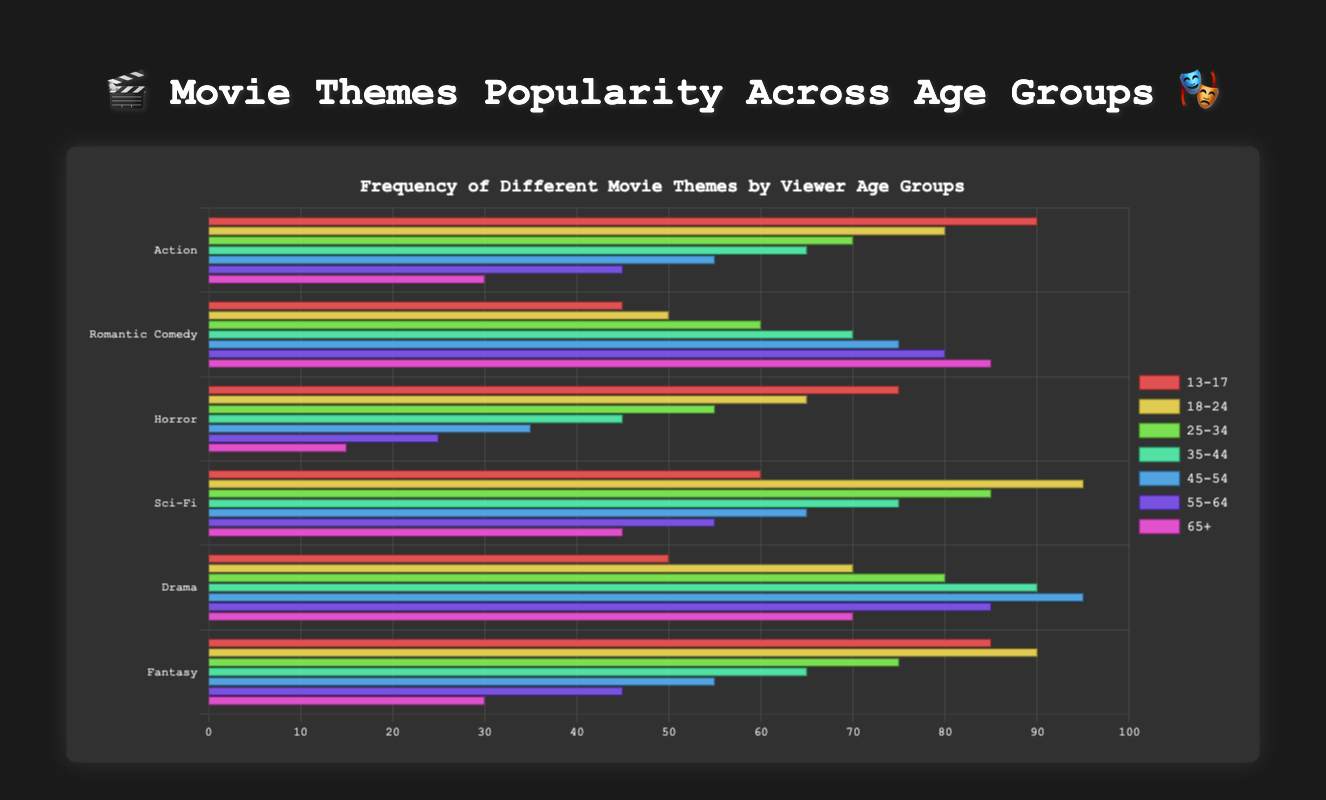Which age group watched Fantasy movies the most? In the chart, look for the longest bar in the Fantasy category. The "13-17" age group has the highest value for Fantasy movies with a bar length corresponding to 85.
Answer: 13-17 What are the two most popular movie themes for the 35-44 age group? For the 35-44 age group, compare the lengths of the bars. Romantic Comedy and Drama have the longest bars with values of 70 and 90, respectively.
Answer: Romantic Comedy, Drama Which movie theme has the lowest overall popularity across all age groups? Assess each theme to find the one with consistently short bars across all age groups. Horror has the lowest value for most age groups with values mostly below 45.
Answer: Horror Is Romantic Comedy more popular than Drama among viewers aged 55-64? Compare the bar lengths for Romantic Comedy and Drama in the 55-64 age group. Romantic Comedy has a value of 80, whereas Drama has a value of 85.
Answer: No What is the difference in popularity of Sci-Fi movies between the 18-24 and 65+ age groups? Subtract the value for Sci-Fi in the 65+ group from the value in the 18-24 group. The 18-24 group's value is 95, and the 65+ group's value is 45. So, 95 - 45 = 50.
Answer: 50 Which themes are equally popular among the 25-34 and 45-54 age groups? Compare the bar lengths of each theme in the 25-34 and 45-54 age groups. Fantasy has equal values in both groups, each with a value of 55.
Answer: Fantasy What is the average popularity of Drama movies across all age groups? Add the values for Drama across all age groups, then divide by the number of age groups. (50 + 70 + 80 + 90 + 95 + 85 + 70) / 7 = 540 / 7 ≈ 77.14.
Answer: 77.14 Which age group has the least interest in Horror movies? Look for the shortest bar in the Horror category. The 65+ age group has the lowest value for Horror movies with a bar length corresponding to 15.
Answer: 65+ What is the total popularity of Action movies across the 13-17 and 18-24 age groups? Add the values for Action movies within the 13-17 and 18-24 age groups. 90 + 80 = 170.
Answer: 170 By how much does the popularity of Romantic Comedy increase from the 13-17 age group to the 65+ age group? Subtract the value for Romantic Comedy in the 13-17 group from the 65+ group. The 13-17 group's value is 45, and the 65+ group's value is 85. So, 85 - 45 = 40.
Answer: 40 